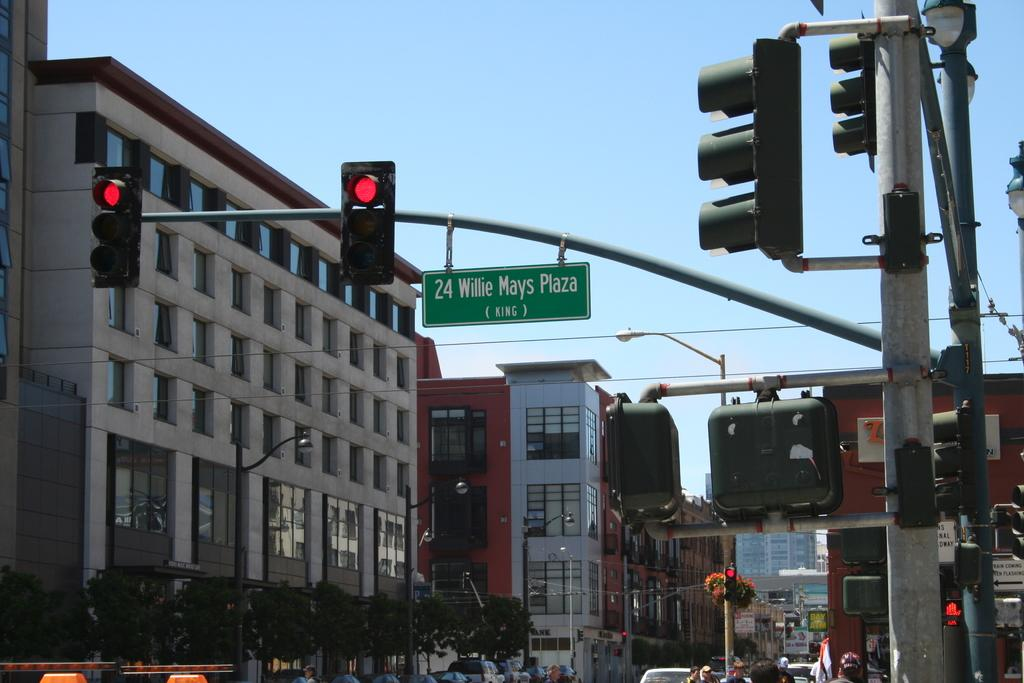Provide a one-sentence caption for the provided image. A street sign for 24 Willie Mays Plaza hangs over the road. 